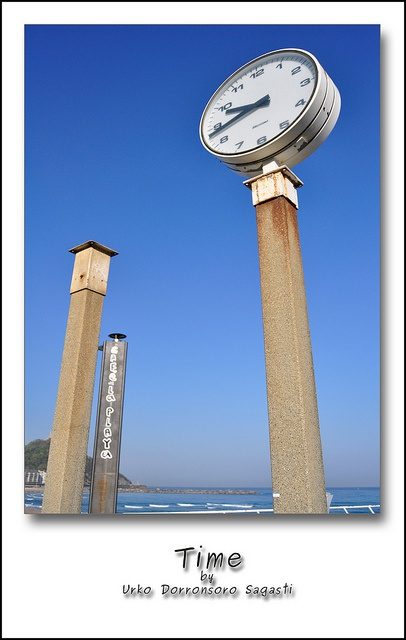Describe the objects in this image and their specific colors. I can see a clock in black, lightgray, darkgray, gray, and blue tones in this image. 